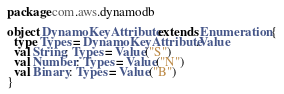<code> <loc_0><loc_0><loc_500><loc_500><_Scala_>package com.aws.dynamodb

object DynamoKeyAttribute extends Enumeration {
  type Types = DynamoKeyAttribute.Value
  val String: Types = Value("S")
  val Number: Types = Value("N")
  val Binary: Types = Value("B")
}
</code> 